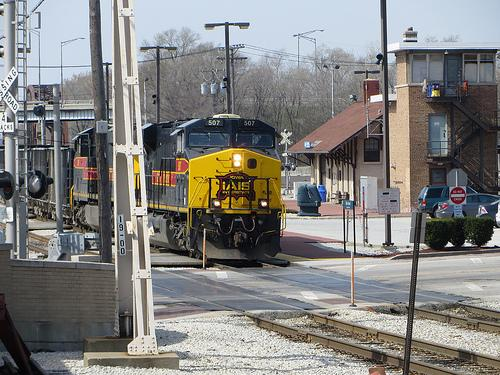Give a brief analysis of the interactions between the objects in the scene. The train is approaching the crossing near parked vehicles, white stones are beside the tracks, and green bushes are in a parking lot, creating a sense of movement and context. Describe any signage or text visible in the image and its significance. There's a white and black railroad crossing sign, a white sticker on a pole, white numbers on the train's front, a "do not enter" sign, and the name on the train's front, all indicating information related to the scene. Identify the notable structures and objects in the scene. Notable structures include a building with a low roof, an external stairway, a grey metal door, a blue container, white stones, and a railroad crossing sign. Estimate the total number of white stones visible in the image. There are at least five clusters of white stones, each containing several stones, so the total number of white stones could be in the range of 20-30 or more. What is the main focus of the image and what are its surroundings? The main focus is a train approaching a street crossing, surrounded by white stones, a railroad crossing sign, green bushes, and parked vehicles. Identify the different types of light sources or signals visible in the image. The light sources include yellow lights visible on the front of the train, and a yellow light on a post near the train. What type of terrain or surface is shown in the image and where is it located? There's gravel near the railroad tracks, a part of a road, part of a ground, and green bushes, all located around the train and the building. Tell me the prominent colors and patterns found in the image. Prominent colors include white, yellow, blue, red, and green. Patterns include yellow and red stripes on a train, white numbers on the front, and a white sticker on the sign. Point out the main transportation mode in the image and describe its features. The main transportation mode is a train, with features such as a yellow front, white numbers on the front, red and yellow stripes on the side, and lights on the front. Provide an emotional impression or sentiment evoked by the scene. The scene evokes a sense of anticipation and daily life, with the train approaching the crossing, parked vehicles, and various elements of the cityscape. Can you identify the pink flowers growing among the small green bushes near the train tracks? They bring a much-needed pop of color to the area. No, it's not mentioned in the image. 